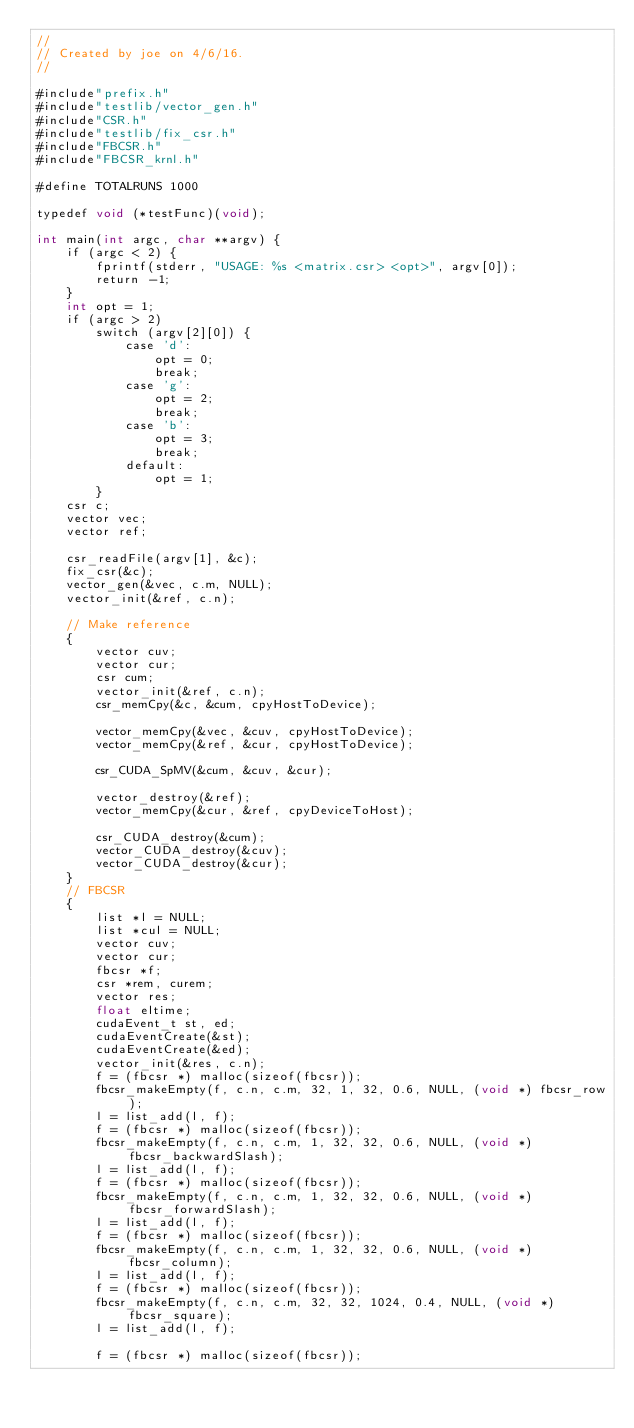Convert code to text. <code><loc_0><loc_0><loc_500><loc_500><_Cuda_>//
// Created by joe on 4/6/16.
//

#include"prefix.h"
#include"testlib/vector_gen.h"
#include"CSR.h"
#include"testlib/fix_csr.h"
#include"FBCSR.h"
#include"FBCSR_krnl.h"

#define TOTALRUNS 1000

typedef void (*testFunc)(void);

int main(int argc, char **argv) {
    if (argc < 2) {
        fprintf(stderr, "USAGE: %s <matrix.csr> <opt>", argv[0]);
        return -1;
    }
    int opt = 1;
    if (argc > 2)
        switch (argv[2][0]) {
            case 'd':
                opt = 0;
                break;
            case 'g':
                opt = 2;
                break;
            case 'b':
                opt = 3;
                break;
            default:
                opt = 1;
        }
    csr c;
    vector vec;
    vector ref;

    csr_readFile(argv[1], &c);
    fix_csr(&c);
    vector_gen(&vec, c.m, NULL);
    vector_init(&ref, c.n);

    // Make reference
    {
        vector cuv;
        vector cur;
        csr cum;
        vector_init(&ref, c.n);
        csr_memCpy(&c, &cum, cpyHostToDevice);

        vector_memCpy(&vec, &cuv, cpyHostToDevice);
        vector_memCpy(&ref, &cur, cpyHostToDevice);

        csr_CUDA_SpMV(&cum, &cuv, &cur);

        vector_destroy(&ref);
        vector_memCpy(&cur, &ref, cpyDeviceToHost);

        csr_CUDA_destroy(&cum);
        vector_CUDA_destroy(&cuv);
        vector_CUDA_destroy(&cur);
    }
    // FBCSR
    {
        list *l = NULL;
        list *cul = NULL;
        vector cuv;
        vector cur;
        fbcsr *f;
        csr *rem, curem;
        vector res;
        float eltime;
        cudaEvent_t st, ed;
        cudaEventCreate(&st);
        cudaEventCreate(&ed);
        vector_init(&res, c.n);
        f = (fbcsr *) malloc(sizeof(fbcsr));
        fbcsr_makeEmpty(f, c.n, c.m, 32, 1, 32, 0.6, NULL, (void *) fbcsr_row);
        l = list_add(l, f);
        f = (fbcsr *) malloc(sizeof(fbcsr));
        fbcsr_makeEmpty(f, c.n, c.m, 1, 32, 32, 0.6, NULL, (void *) fbcsr_backwardSlash);
        l = list_add(l, f);
        f = (fbcsr *) malloc(sizeof(fbcsr));
        fbcsr_makeEmpty(f, c.n, c.m, 1, 32, 32, 0.6, NULL, (void *) fbcsr_forwardSlash);
        l = list_add(l, f);
        f = (fbcsr *) malloc(sizeof(fbcsr));
        fbcsr_makeEmpty(f, c.n, c.m, 1, 32, 32, 0.6, NULL, (void *) fbcsr_column);
        l = list_add(l, f);
        f = (fbcsr *) malloc(sizeof(fbcsr));
        fbcsr_makeEmpty(f, c.n, c.m, 32, 32, 1024, 0.4, NULL, (void *) fbcsr_square);
        l = list_add(l, f);

        f = (fbcsr *) malloc(sizeof(fbcsr));</code> 